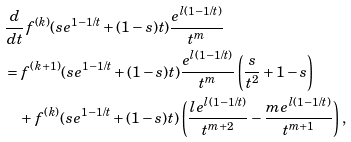Convert formula to latex. <formula><loc_0><loc_0><loc_500><loc_500>& \frac { d } { d t } f ^ { ( k ) } ( s e ^ { 1 - 1 / t } + ( 1 - s ) t ) \frac { e ^ { l ( 1 - 1 / t ) } } { t ^ { m } } \\ & = f ^ { ( k + 1 ) } ( s e ^ { 1 - 1 / t } + ( 1 - s ) t ) \frac { e ^ { l ( 1 - 1 / t ) } } { t ^ { m } } \left ( \frac { s } { t ^ { 2 } } + 1 - s \right ) \\ & \quad + f ^ { ( k ) } ( s e ^ { 1 - 1 / t } + ( 1 - s ) t ) \left ( \frac { l e ^ { l ( 1 - 1 / t ) } } { t ^ { m + 2 } } - \frac { m e ^ { l ( 1 - 1 / t ) } } { t ^ { m + 1 } } \right ) ,</formula> 